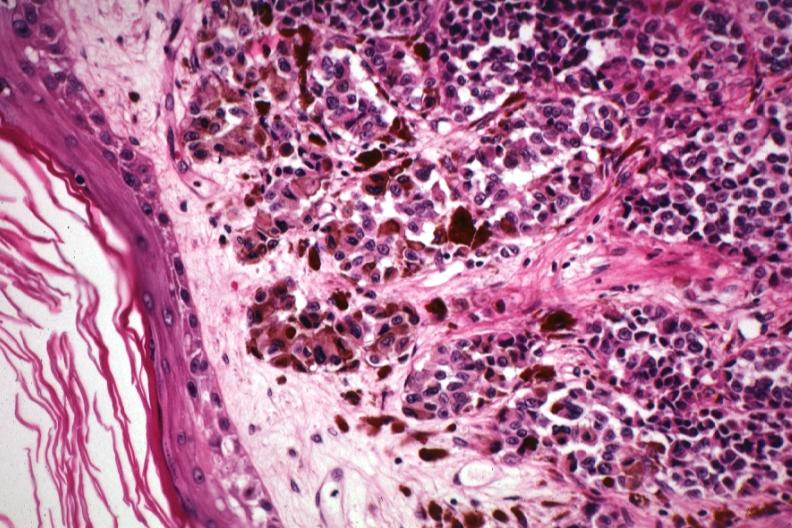s lung present?
Answer the question using a single word or phrase. No 